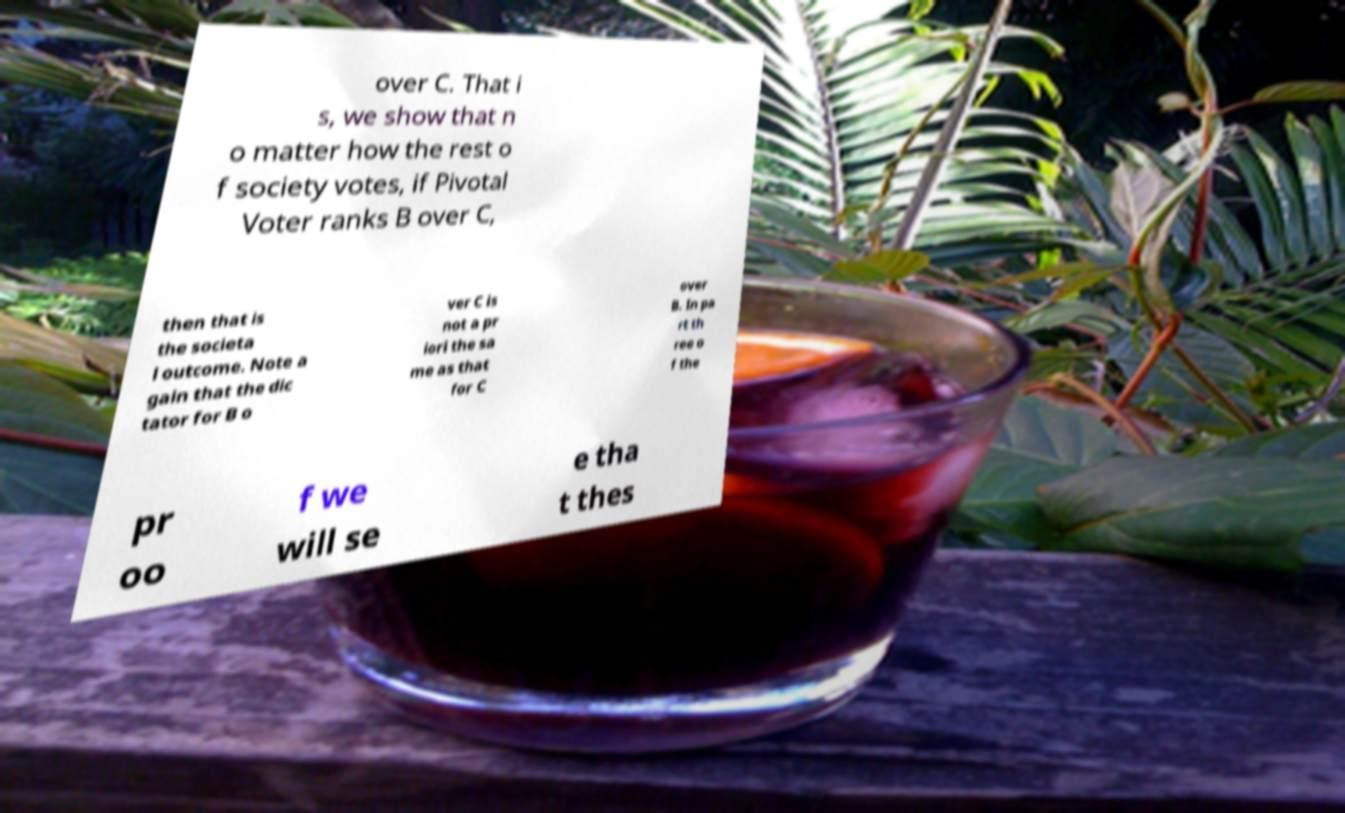Please read and relay the text visible in this image. What does it say? over C. That i s, we show that n o matter how the rest o f society votes, if Pivotal Voter ranks B over C, then that is the societa l outcome. Note a gain that the dic tator for B o ver C is not a pr iori the sa me as that for C over B. In pa rt th ree o f the pr oo f we will se e tha t thes 